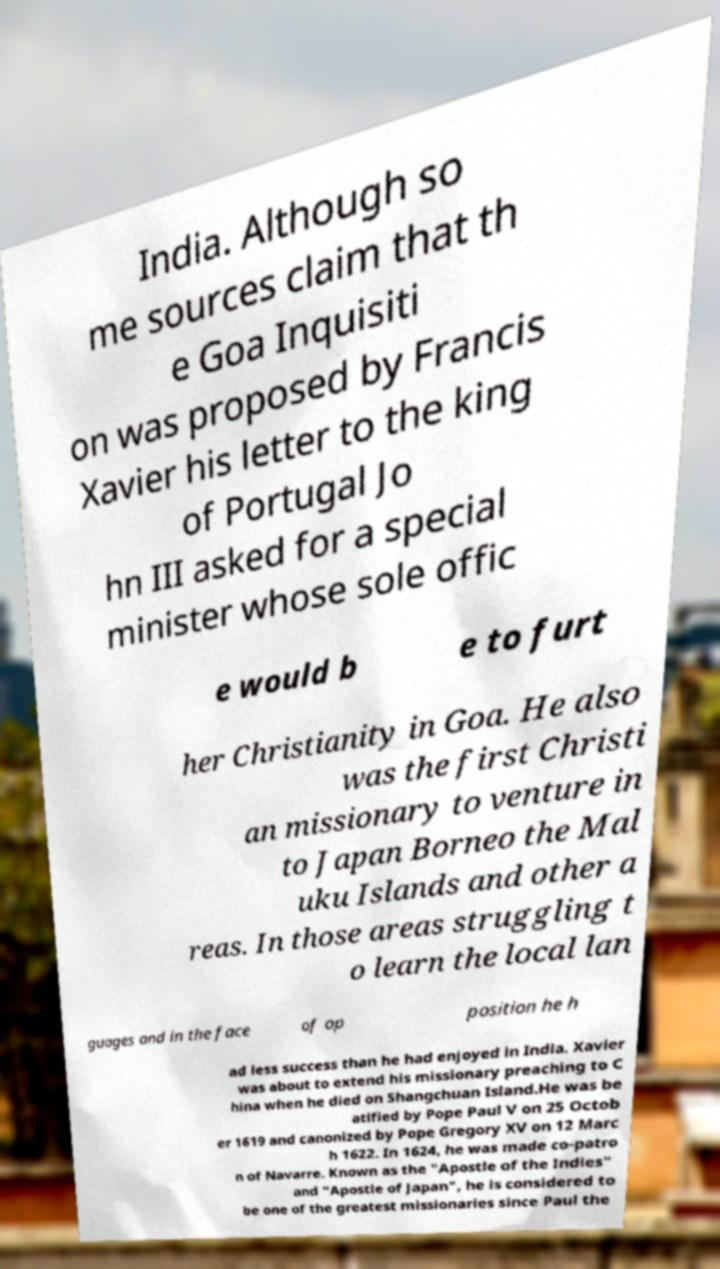I need the written content from this picture converted into text. Can you do that? India. Although so me sources claim that th e Goa Inquisiti on was proposed by Francis Xavier his letter to the king of Portugal Jo hn III asked for a special minister whose sole offic e would b e to furt her Christianity in Goa. He also was the first Christi an missionary to venture in to Japan Borneo the Mal uku Islands and other a reas. In those areas struggling t o learn the local lan guages and in the face of op position he h ad less success than he had enjoyed in India. Xavier was about to extend his missionary preaching to C hina when he died on Shangchuan Island.He was be atified by Pope Paul V on 25 Octob er 1619 and canonized by Pope Gregory XV on 12 Marc h 1622. In 1624, he was made co-patro n of Navarre. Known as the "Apostle of the Indies" and "Apostle of Japan", he is considered to be one of the greatest missionaries since Paul the 